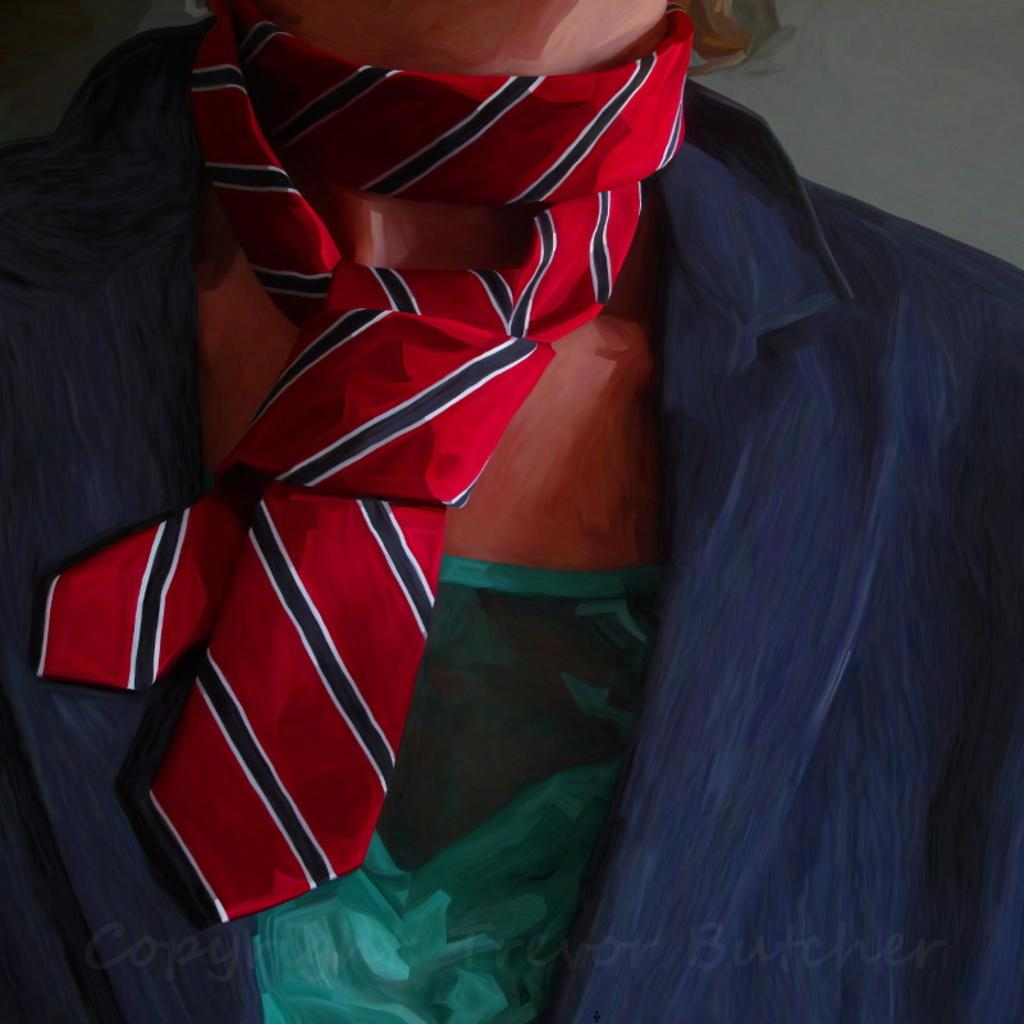What is the main subject of the image? There is a painting in the image. What is happening in the painting? A person is standing in the painting. What is the person wearing in the painting? The person is wearing a suit and a tie. What type of bread is being used to settle the argument in the painting? There is no bread or argument present in the painting; it features a person wearing a suit and a tie. 